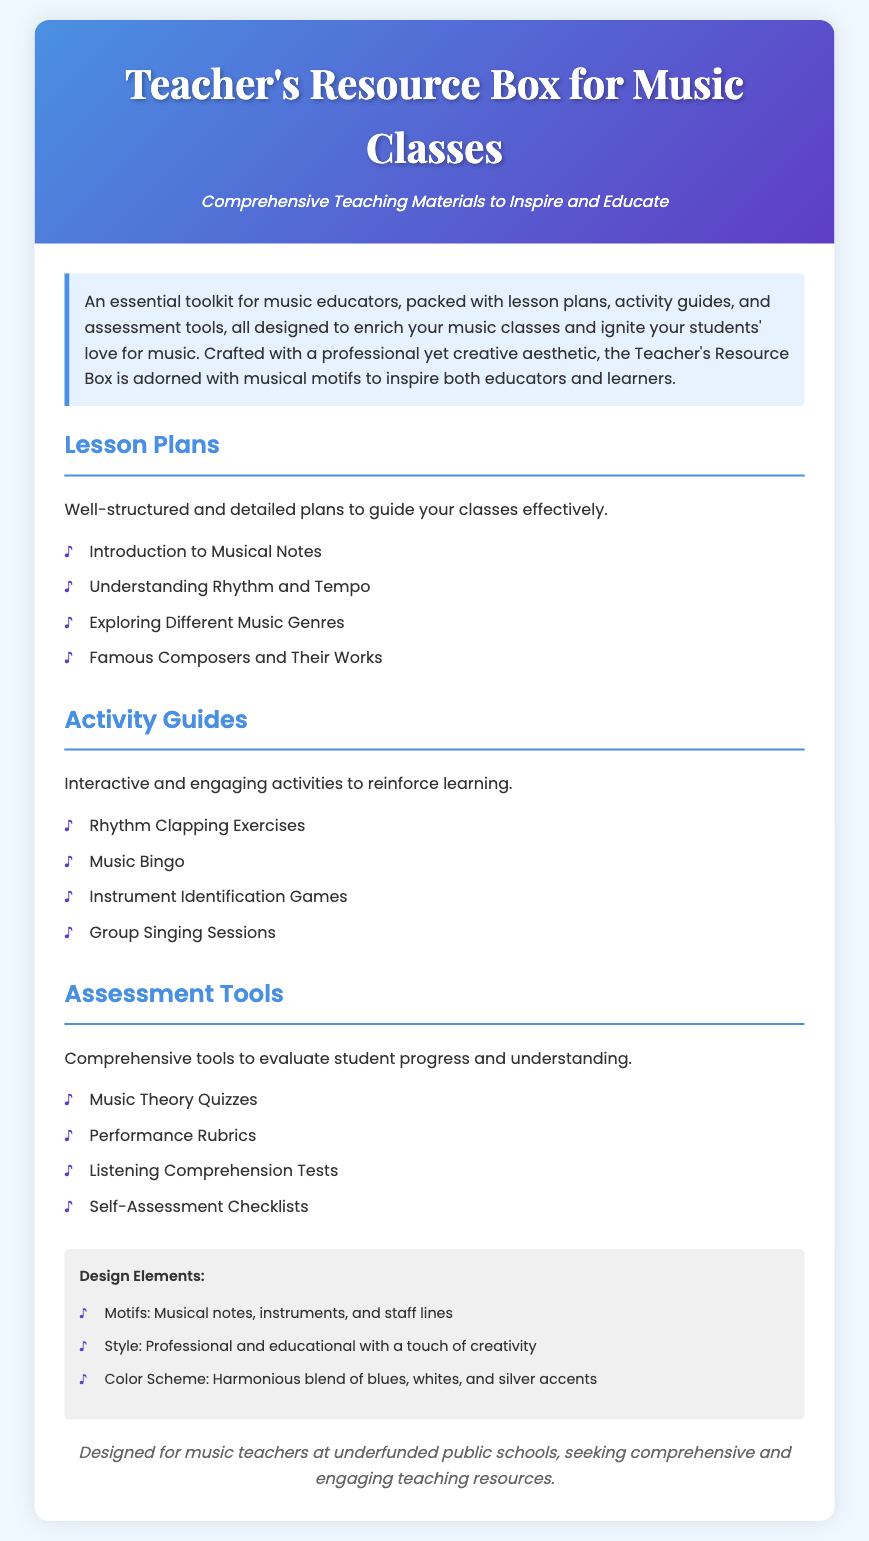What is the main purpose of the Teacher's Resource Box? The document describes the main purpose as providing comprehensive teaching materials to inspire and educate music educators.
Answer: Comprehensive Teaching Materials to Inspire and Educate How many sections are there in the resource box? The document lists three primary sections: Lesson Plans, Activity Guides, and Assessment Tools.
Answer: Three What is one example of an activity guide included? The document provides a list, and one of the activities mentioned is Music Bingo.
Answer: Music Bingo What motifs are used in the design elements? The document mentions that the design includes motifs such as musical notes and instruments.
Answer: Musical notes, instruments, and staff lines Who is the target audience for this resource box? The document specifies that it is designed for music teachers at underfunded public schools.
Answer: Music teachers at underfunded public schools How is the color scheme described? The document describes the color scheme as a harmonious blend.
Answer: Harmonious blend of blues, whites, and silver accents What type of quizzes are included in the assessment tools? The document provides examples including Music Theory Quizzes as part of the assessment tools.
Answer: Music Theory Quizzes What is the tone of the packaging's design? The document describes the design's tone as professional and educational with a touch of creativity.
Answer: Professional and educational with a touch of creativity What is the first lesson plan topic listed? According to the document, the first lesson plan topic is Introduction to Musical Notes.
Answer: Introduction to Musical Notes 